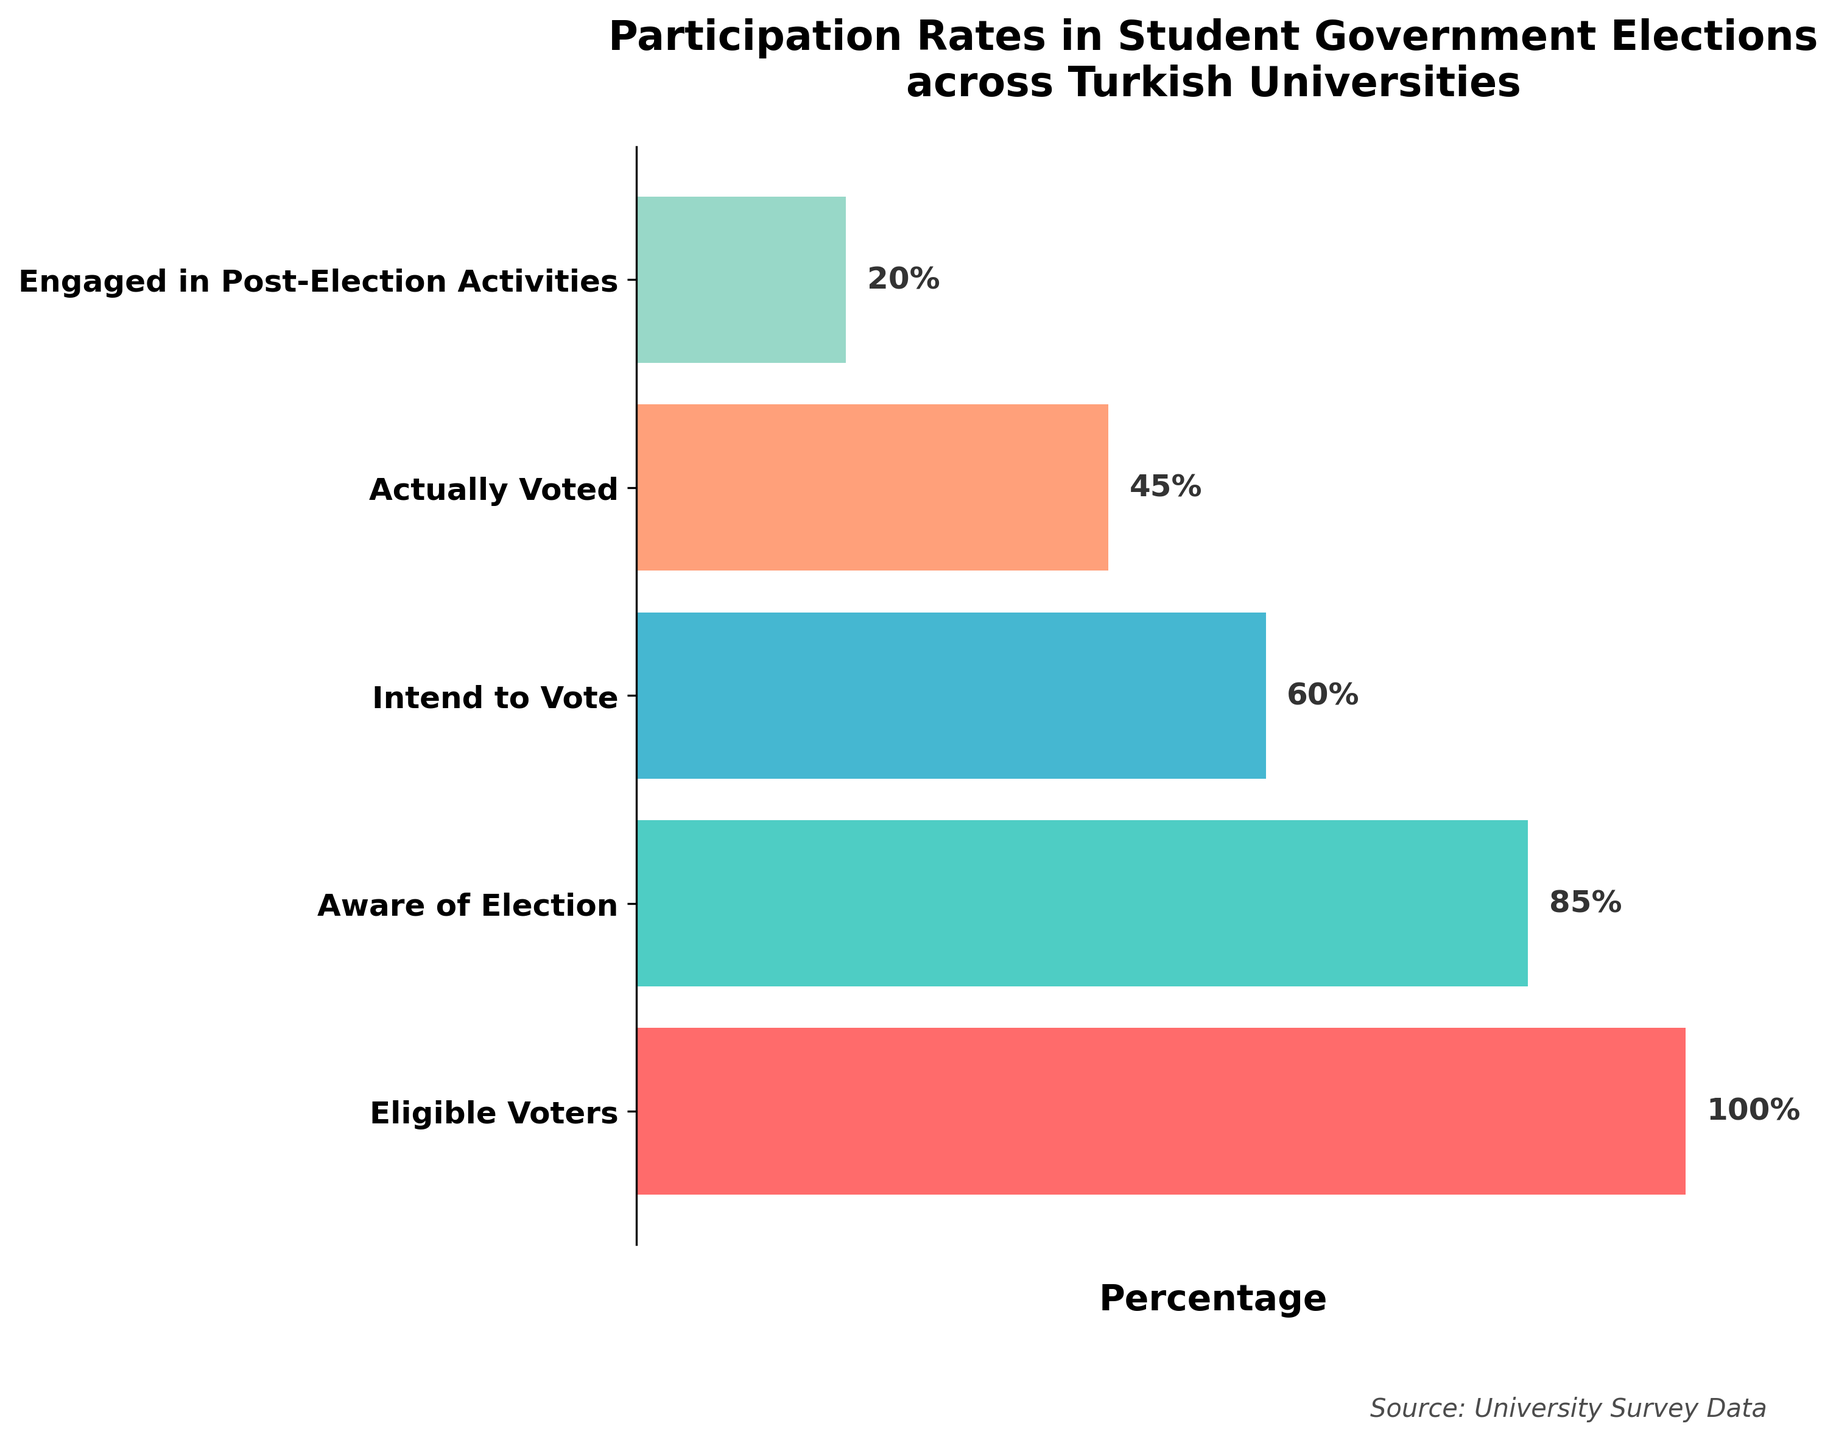What is the title of the plot? The title is written at the top of the plot. It reads "Participation Rates in Student Government Elections across Turkish Universities."
Answer: Participation Rates in Student Government Elections across Turkish Universities What percentage of eligible voters are aware of the election? In the plot, the bar corresponding to the stage "Aware of Election" has a percentage label.
Answer: 85% How much drop-off is there from those who intend to vote to those who actually voted? Subtract the percentage who actually voted (45%) from the percentage who intend to vote (60%). 60% - 45% = 15%.
Answer: 15% What is the least attended stage in terms of percentage? The smallest bar in terms of percentage labels is referred to as "Engaged in Post-Election Activities" which has a label showing 20%.
Answer: Engaged in Post-Election Activities Which stages involve more than half of the eligible voters? Identify bars with percentages greater than 50%. Eligible Voters (100%), Aware of Election (85%), and Intend to Vote (60%) meet this criterion.
Answer: Eligible Voters, Aware of Election, Intend to Vote What is the relative difference in percentages between those who are aware of the election and those who voted? Calculate the relative difference: ((85% - 45%) / 85%) * 100 = 47.1%.
Answer: 47.1% If there are 1000 eligible voters, how many students actually voted? Calculate the number of students based on the percentage: 1000 * 0.45 = 450 students.
Answer: 450 How does engagement in post-election activities compare to those who actually voted, percentage-wise? Compare the percentages of the two stages "Engaged in Post-Election Activities" (20%) and "Actually Voted" (45%): 45% - 20% = 25%.
Answer: 25% What stage saw the biggest decrease in percentage compared to its preceding stage? Calculate the differences between adjacent stages: (Eligible Voters 100% to Aware of Election 85% => 15%), (Aware of Election 85% to Intend to Vote 60% => 25%), (Intend to Vote 60% to Actually Voted 45% => 15%), (Actually Voted 45% to Engaged in Post-Election Activities 20% => 25%). The largest difference is from "Intend to Vote" to "Actually Voted" and "Actually Voted" to "Engaged in Post-Election Activities", both at 25%.
Answer: Intend to Vote to Actually Voted and Actually Voted to Engaged in Post-Election Activities What is the cumulative drop-off from eligible voters to the stage of engaged in post-election activities? Subtract the percentage engaged in post-election activities (20%) from eligible voters (100%): 100% - 20% = 80%.
Answer: 80% 